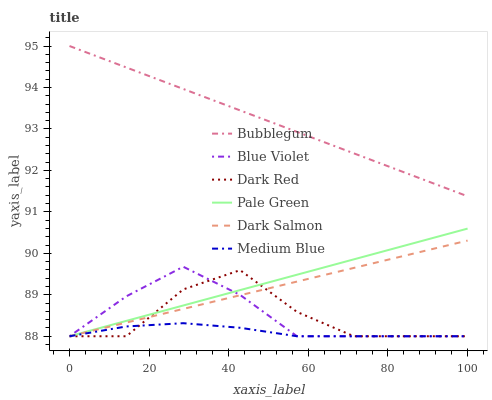Does Medium Blue have the minimum area under the curve?
Answer yes or no. Yes. Does Bubblegum have the maximum area under the curve?
Answer yes or no. Yes. Does Dark Salmon have the minimum area under the curve?
Answer yes or no. No. Does Dark Salmon have the maximum area under the curve?
Answer yes or no. No. Is Dark Salmon the smoothest?
Answer yes or no. Yes. Is Dark Red the roughest?
Answer yes or no. Yes. Is Medium Blue the smoothest?
Answer yes or no. No. Is Medium Blue the roughest?
Answer yes or no. No. Does Dark Red have the lowest value?
Answer yes or no. Yes. Does Bubblegum have the lowest value?
Answer yes or no. No. Does Bubblegum have the highest value?
Answer yes or no. Yes. Does Dark Salmon have the highest value?
Answer yes or no. No. Is Medium Blue less than Bubblegum?
Answer yes or no. Yes. Is Bubblegum greater than Blue Violet?
Answer yes or no. Yes. Does Dark Red intersect Dark Salmon?
Answer yes or no. Yes. Is Dark Red less than Dark Salmon?
Answer yes or no. No. Is Dark Red greater than Dark Salmon?
Answer yes or no. No. Does Medium Blue intersect Bubblegum?
Answer yes or no. No. 